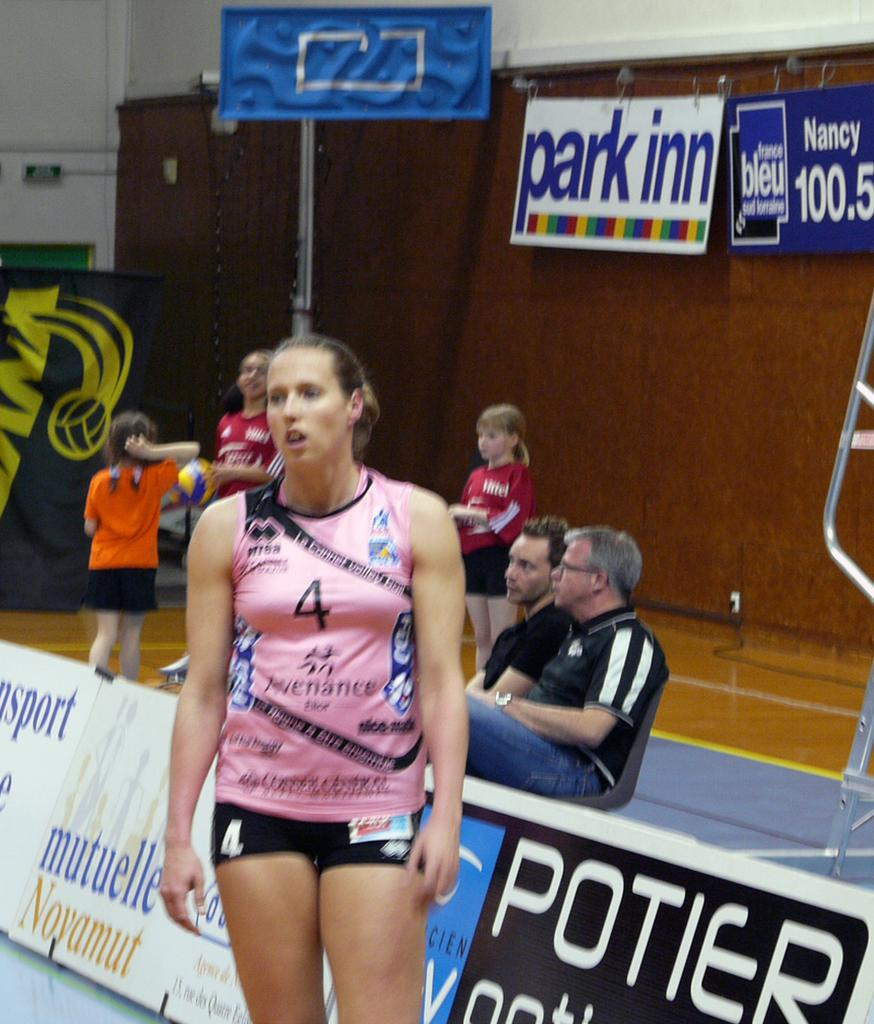Provide a one-sentence caption for the provided image. Girl participating in either baseball or gymnastics, she is # 4. 